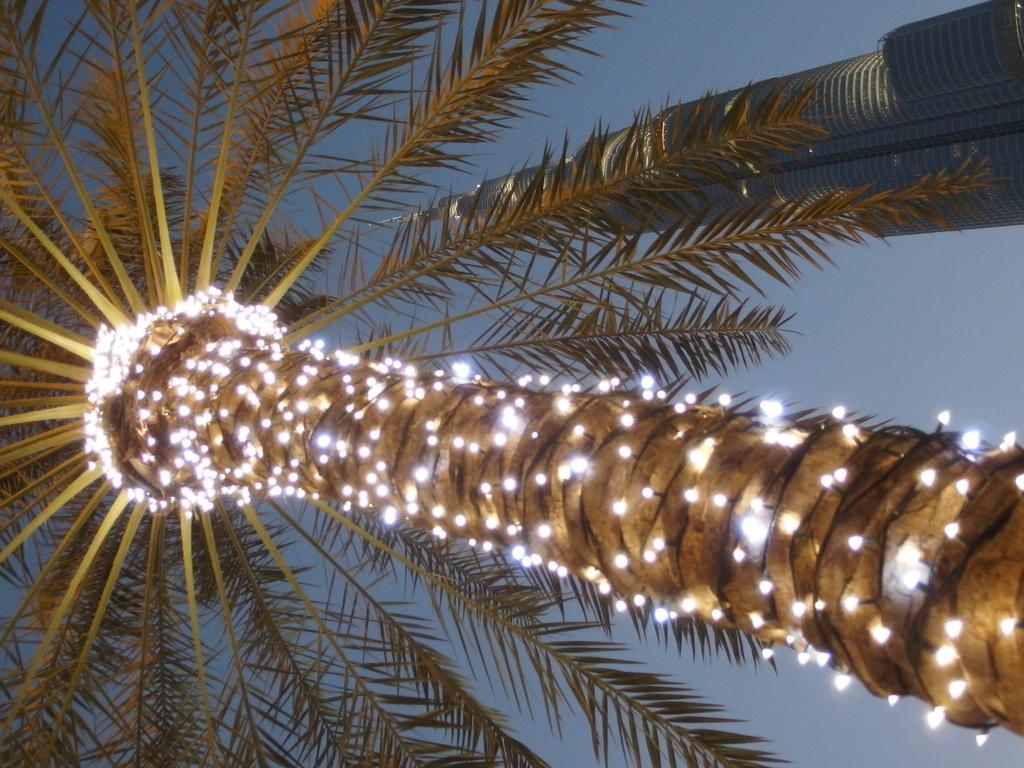What is the main subject in the middle of the image? There is a tree with lights in the image. Where is the tree located in relation to the rest of the image? The tree is in the middle of the image. What other structure can be seen in the image? There is a tower in the top right corner of the image. What can be seen in the background of the image? The sky is visible in the background of the image. How many toothbrushes are hanging from the tree in the image? There are no toothbrushes present in the image; it features a tree with lights. What type of copy is being made in the image? There is no copying activity depicted in the image; it shows a tree with lights and a tower. 